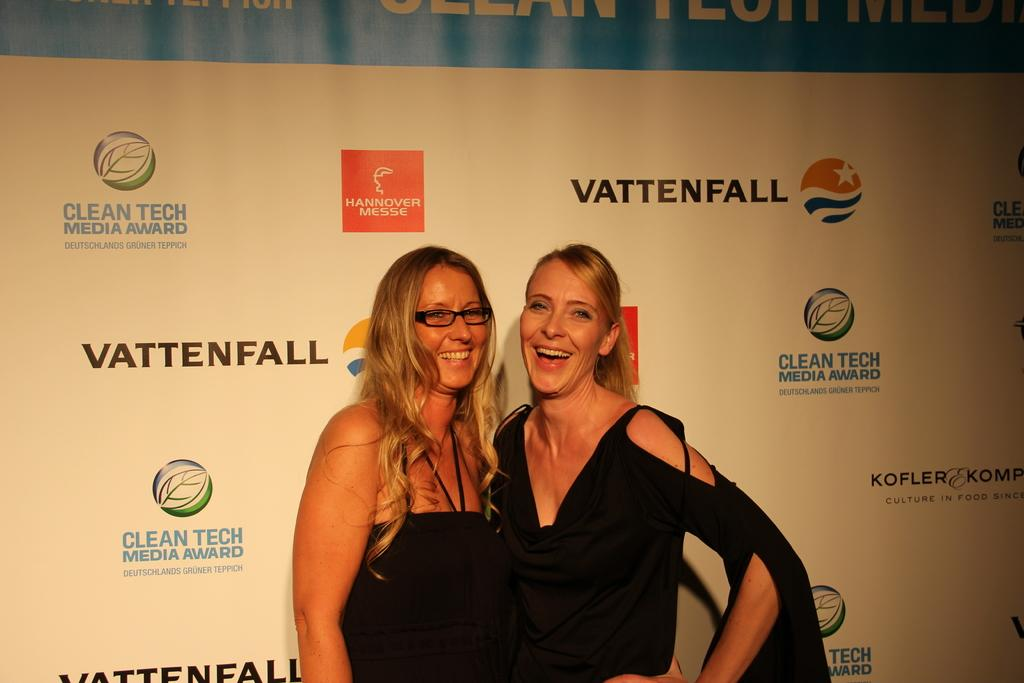How many girls are present in the image? There are two girls in the image. What are the girls doing in the image? The girls are standing beside each other in the middle of the image. What can be seen in the background of the image? There is a banner in the background of the image. What is the appearance of the girl on the left side? The girl on the left side is wearing spectacles. What type of mint can be seen growing near the girls in the image? There is no mint visible in the image; it only features two girls standing beside each other and a banner in the background. 